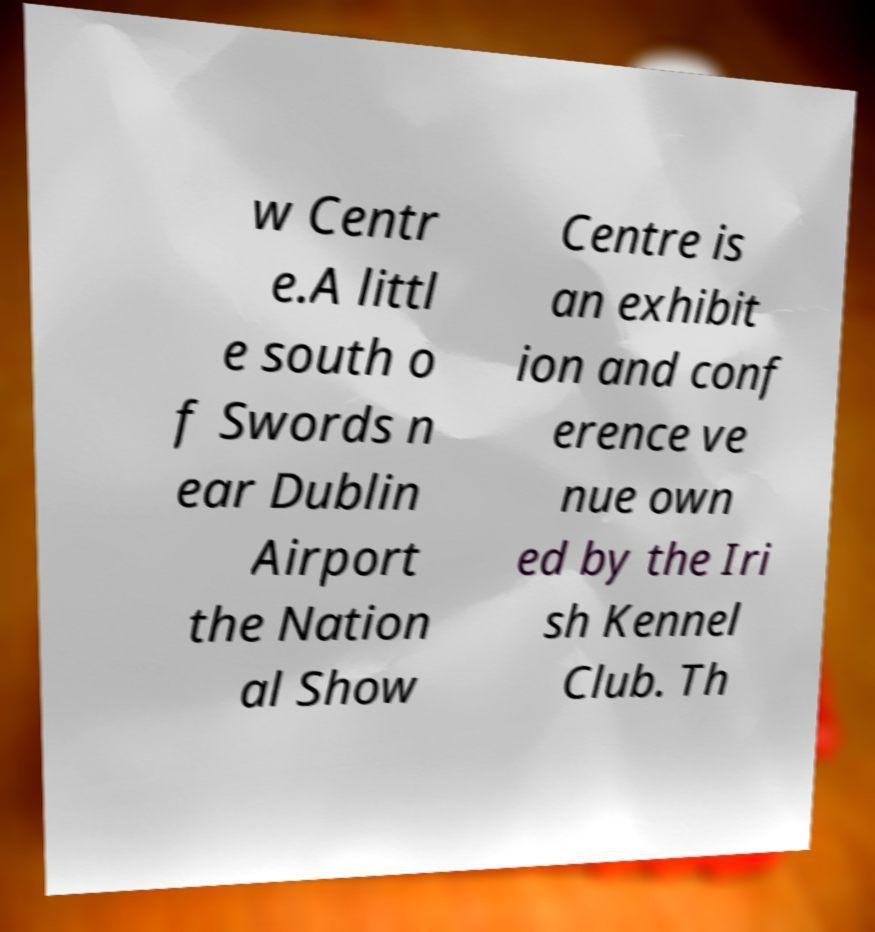For documentation purposes, I need the text within this image transcribed. Could you provide that? w Centr e.A littl e south o f Swords n ear Dublin Airport the Nation al Show Centre is an exhibit ion and conf erence ve nue own ed by the Iri sh Kennel Club. Th 